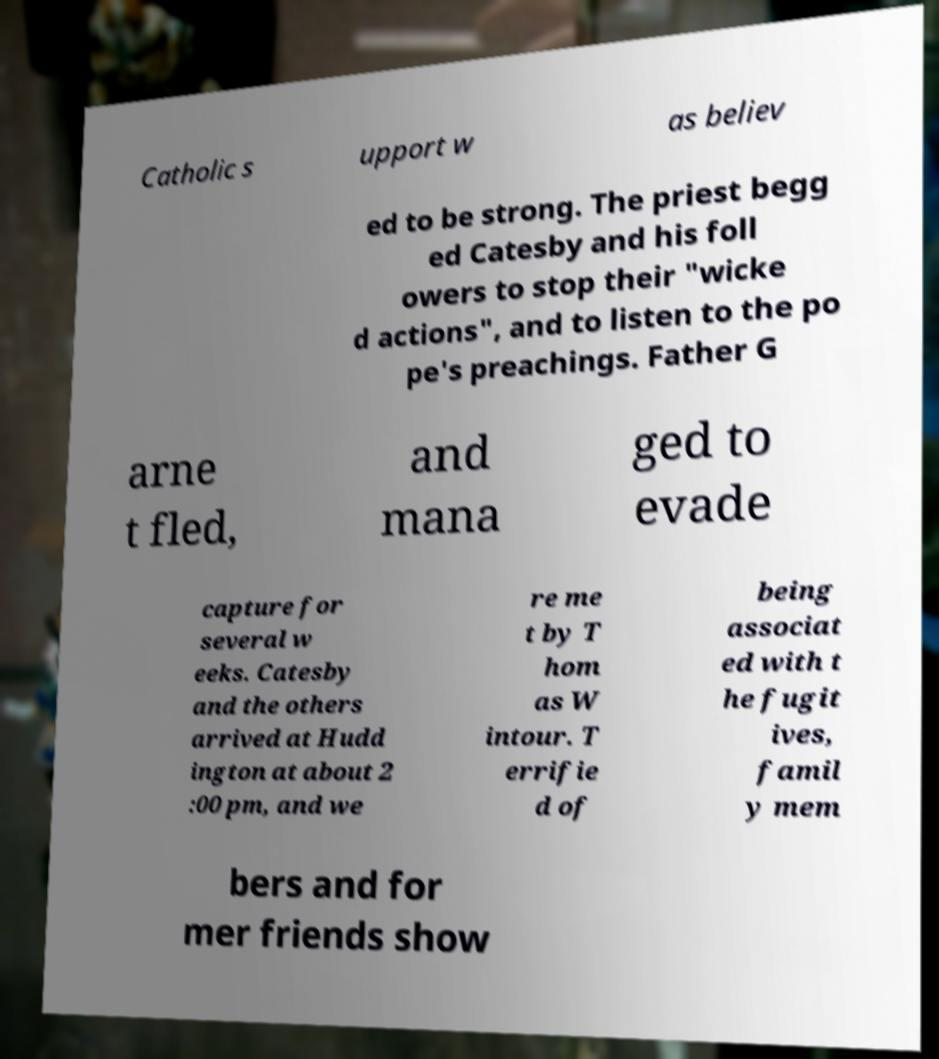Please identify and transcribe the text found in this image. Catholic s upport w as believ ed to be strong. The priest begg ed Catesby and his foll owers to stop their "wicke d actions", and to listen to the po pe's preachings. Father G arne t fled, and mana ged to evade capture for several w eeks. Catesby and the others arrived at Hudd ington at about 2 :00 pm, and we re me t by T hom as W intour. T errifie d of being associat ed with t he fugit ives, famil y mem bers and for mer friends show 